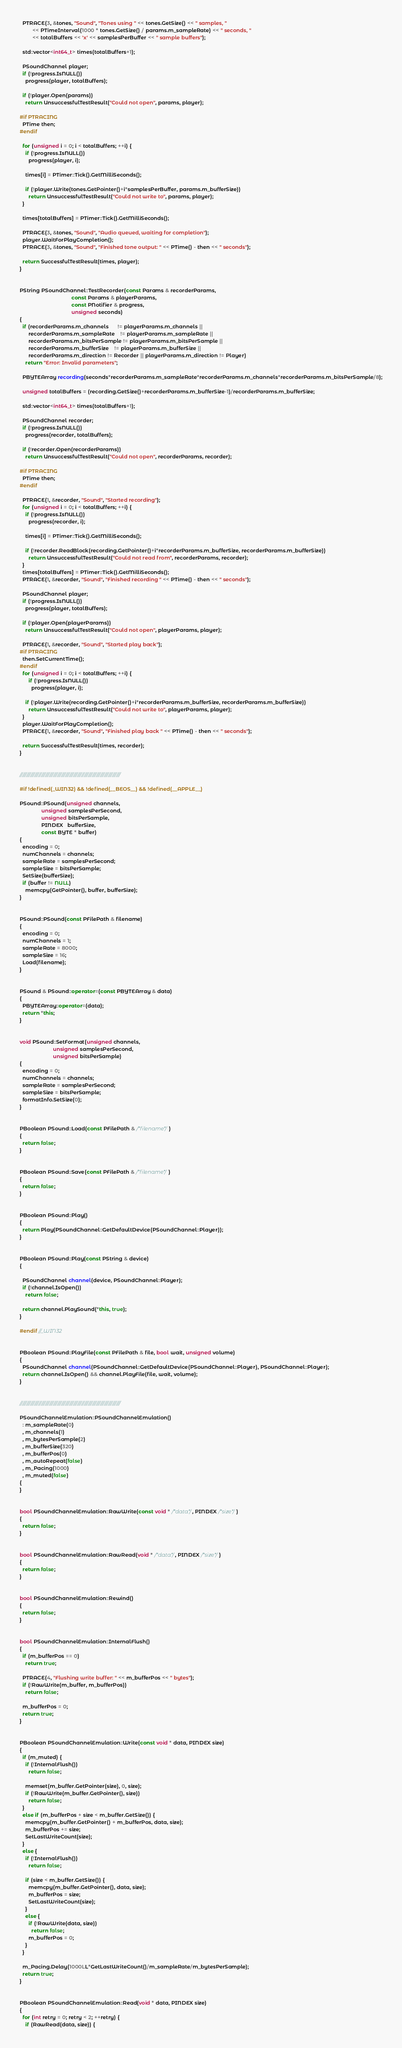Convert code to text. <code><loc_0><loc_0><loc_500><loc_500><_C++_>  PTRACE(3, &tones, "Sound", "Tones using " << tones.GetSize() << " samples, "
         << PTimeInterval(1000 * tones.GetSize() / params.m_sampleRate) << " seconds, "
         << totalBuffers << 'x' << samplesPerBuffer << " sample buffers");

  std::vector<int64_t> times(totalBuffers+1);

  PSoundChannel player;
  if (!progress.IsNULL())
    progress(player, totalBuffers);

  if (!player.Open(params))
    return UnsuccessfulTestResult("Could not open", params, player);

#if PTRACING
  PTime then;
#endif

  for (unsigned i = 0; i < totalBuffers; ++i) {
    if (!progress.IsNULL())
      progress(player, i);

    times[i] = PTimer::Tick().GetMilliSeconds();

    if (!player.Write(tones.GetPointer()+i*samplesPerBuffer, params.m_bufferSize))
      return UnsuccessfulTestResult("Could not write to", params, player);
  }

  times[totalBuffers] = PTimer::Tick().GetMilliSeconds();

  PTRACE(3, &tones, "Sound", "Audio queued, waiting for completion");
  player.WaitForPlayCompletion();
  PTRACE(3, &tones, "Sound", "Finished tone output: " << PTime() - then << " seconds");

  return SuccessfulTestResult(times, player);
}


PString PSoundChannel::TestRecorder(const Params & recorderParams,
                                    const Params & playerParams,
                                    const PNotifier & progress,
                                    unsigned seconds)
{
  if (recorderParams.m_channels      != playerParams.m_channels ||
      recorderParams.m_sampleRate    != playerParams.m_sampleRate ||
      recorderParams.m_bitsPerSample != playerParams.m_bitsPerSample ||
      recorderParams.m_bufferSize    != playerParams.m_bufferSize ||
      recorderParams.m_direction != Recorder || playerParams.m_direction != Player)
    return "Error: Invalid parameters";

  PBYTEArray recording(seconds*recorderParams.m_sampleRate*recorderParams.m_channels*recorderParams.m_bitsPerSample/8);

  unsigned totalBuffers = (recording.GetSize()+recorderParams.m_bufferSize-1)/recorderParams.m_bufferSize;

  std::vector<int64_t> times(totalBuffers+1);

  PSoundChannel recorder;
  if (!progress.IsNULL())
    progress(recorder, totalBuffers);

  if (!recorder.Open(recorderParams))
    return UnsuccessfulTestResult("Could not open", recorderParams, recorder);
  
#if PTRACING
  PTime then;
#endif

  PTRACE(1, &recorder, "Sound", "Started recording");
  for (unsigned i = 0; i < totalBuffers; ++i) {
    if (!progress.IsNULL())
      progress(recorder, i);

    times[i] = PTimer::Tick().GetMilliSeconds();

    if (!recorder.ReadBlock(recording.GetPointer()+i*recorderParams.m_bufferSize, recorderParams.m_bufferSize))
      return UnsuccessfulTestResult("Could not read from", recorderParams, recorder);
  }
  times[totalBuffers] = PTimer::Tick().GetMilliSeconds();
  PTRACE(1, &recorder, "Sound", "Finished recording " << PTime() - then << " seconds");

  PSoundChannel player;
  if (!progress.IsNULL())
    progress(player, totalBuffers);

  if (!player.Open(playerParams))
    return UnsuccessfulTestResult("Could not open", playerParams, player);

  PTRACE(1, &recorder, "Sound", "Started play back");
#if PTRACING
  then.SetCurrentTime();
#endif
  for (unsigned i = 0; i < totalBuffers; ++i) {
      if (!progress.IsNULL())
        progress(player, i);

    if (!player.Write(recording.GetPointer()+i*recorderParams.m_bufferSize, recorderParams.m_bufferSize))
      return UnsuccessfulTestResult("Could not write to", playerParams, player);
  }
  player.WaitForPlayCompletion();
  PTRACE(1, &recorder, "Sound", "Finished play back " << PTime() - then << " seconds");

  return SuccessfulTestResult(times, recorder);
}


///////////////////////////////////////////////////////////////////////////

#if !defined(_WIN32) && !defined(__BEOS__) && !defined(__APPLE__)

PSound::PSound(unsigned channels,
               unsigned samplesPerSecond,
               unsigned bitsPerSample,
               PINDEX   bufferSize,
               const BYTE * buffer)
{
  encoding = 0;
  numChannels = channels;
  sampleRate = samplesPerSecond;
  sampleSize = bitsPerSample;
  SetSize(bufferSize);
  if (buffer != NULL)
    memcpy(GetPointer(), buffer, bufferSize);
}


PSound::PSound(const PFilePath & filename)
{
  encoding = 0;
  numChannels = 1;
  sampleRate = 8000;
  sampleSize = 16;
  Load(filename);
}


PSound & PSound::operator=(const PBYTEArray & data)
{
  PBYTEArray::operator=(data);
  return *this;
}


void PSound::SetFormat(unsigned channels,
                       unsigned samplesPerSecond,
                       unsigned bitsPerSample)
{
  encoding = 0;
  numChannels = channels;
  sampleRate = samplesPerSecond;
  sampleSize = bitsPerSample;
  formatInfo.SetSize(0);
}


PBoolean PSound::Load(const PFilePath & /*filename*/)
{
  return false;
}


PBoolean PSound::Save(const PFilePath & /*filename*/)
{
  return false;
}


PBoolean PSound::Play()
{
  return Play(PSoundChannel::GetDefaultDevice(PSoundChannel::Player));
}


PBoolean PSound::Play(const PString & device)
{

  PSoundChannel channel(device, PSoundChannel::Player);
  if (!channel.IsOpen())
    return false;

  return channel.PlaySound(*this, true);
}

#endif //_WIN32


PBoolean PSound::PlayFile(const PFilePath & file, bool wait, unsigned volume)
{
  PSoundChannel channel(PSoundChannel::GetDefaultDevice(PSoundChannel::Player), PSoundChannel::Player);
  return channel.IsOpen() && channel.PlayFile(file, wait, volume);
}


///////////////////////////////////////////////////////////////////////////

PSoundChannelEmulation::PSoundChannelEmulation()
  : m_sampleRate(0)
  , m_channels(1)
  , m_bytesPerSample(2)
  , m_bufferSize(320)
  , m_bufferPos(0)
  , m_autoRepeat(false)
  , m_Pacing(1000)
  , m_muted(false)
{
}


bool PSoundChannelEmulation::RawWrite(const void * /*data*/, PINDEX /*size*/)
{
  return false;
}


bool PSoundChannelEmulation::RawRead(void * /*data*/, PINDEX /*size*/)
{
  return false;
}


bool PSoundChannelEmulation::Rewind()
{
  return false;
}


bool PSoundChannelEmulation::InternalFlush()
{
  if (m_bufferPos == 0)
    return true;

  PTRACE(4, "Flushing write buffer: " << m_bufferPos << " bytes");
  if (!RawWrite(m_buffer, m_bufferPos))
    return false;

  m_bufferPos = 0;
  return true;
}


PBoolean PSoundChannelEmulation::Write(const void * data, PINDEX size)
{
  if (m_muted) {
    if (!InternalFlush())
      return false;

    memset(m_buffer.GetPointer(size), 0, size);
    if (!RawWrite(m_buffer.GetPointer(), size))
      return false;
  }
  else if (m_bufferPos + size < m_buffer.GetSize()) {
    memcpy(m_buffer.GetPointer() + m_bufferPos, data, size);
    m_bufferPos += size;
    SetLastWriteCount(size);
  }
  else {
    if (!InternalFlush())
      return false;

    if (size < m_buffer.GetSize()) {
      memcpy(m_buffer.GetPointer(), data, size);
      m_bufferPos = size;
      SetLastWriteCount(size);
    }
    else {
      if (!RawWrite(data, size))
        return false;
      m_bufferPos = 0;
    }
  }

  m_Pacing.Delay(1000LL*GetLastWriteCount()/m_sampleRate/m_bytesPerSample);
  return true;
}


PBoolean PSoundChannelEmulation::Read(void * data, PINDEX size)
{
  for (int retry = 0; retry < 2; ++retry) {
    if (RawRead(data, size)) {</code> 